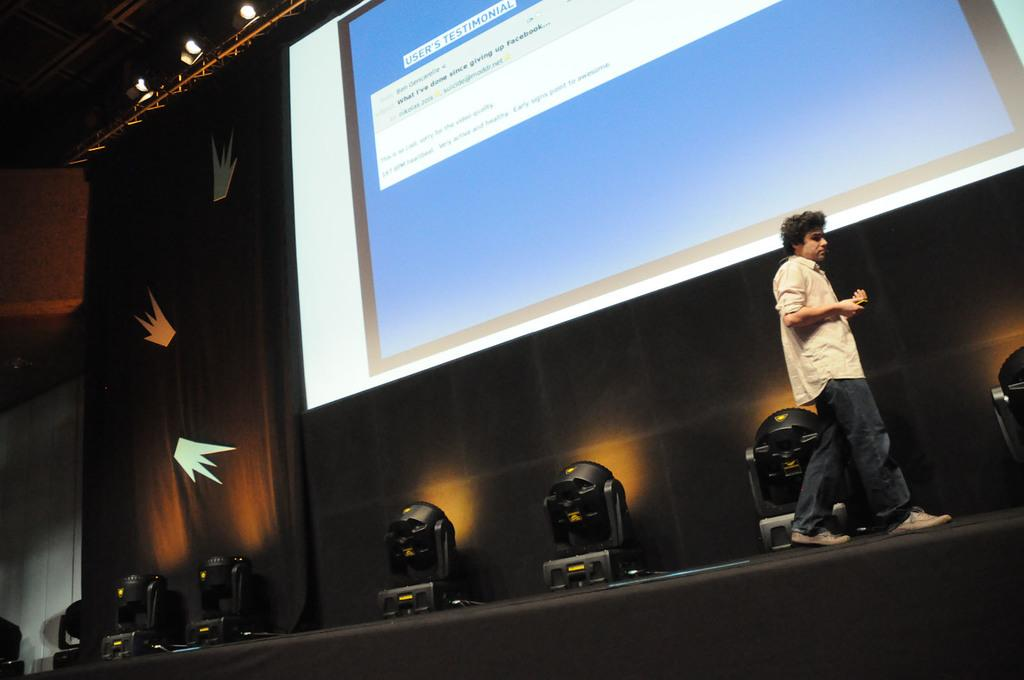What is the person in the image doing? There is a person walking on the stage in the image. What can be seen illuminating the stage? There are spotlights in the image. What is present in the background of the image? There are curtains and a screen in the background of the image. What type of grain is being harvested in the image? There is no grain or harvesting activity present in the image; it features a person walking on a stage with spotlights, curtains, and a screen in the background. 